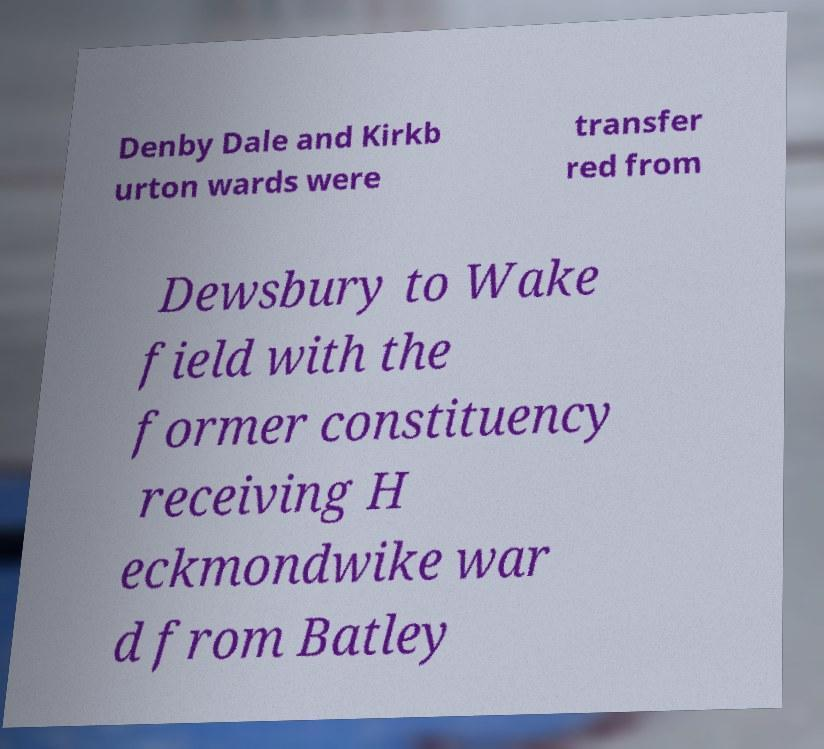For documentation purposes, I need the text within this image transcribed. Could you provide that? Denby Dale and Kirkb urton wards were transfer red from Dewsbury to Wake field with the former constituency receiving H eckmondwike war d from Batley 